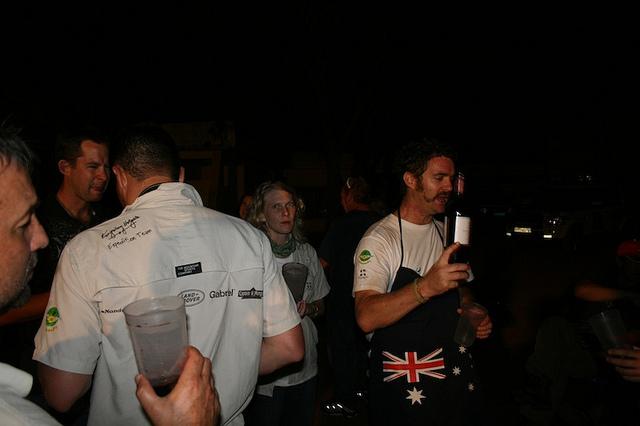How many bottles are seen?
Write a very short answer. 1. How many people?
Short answer required. 5. What are they celebrating?
Give a very brief answer. Birthday. Why are they standing this way?
Be succinct. Drinking. What is the man in the all white shirt holding?
Concise answer only. Wine. Are these guys having a celebration?
Quick response, please. Yes. What is behind the man?
Short answer required. People. What are the men holding?
Short answer required. Drinks. Is this a party?
Concise answer only. Yes. Do you see something on the men's heads?
Be succinct. No. What is this man carrying?
Concise answer only. Wine. How many umbrellas are visible in this photo?
Keep it brief. 0. Does the person holding the bottle have a mustache?
Concise answer only. Yes. How many bald men are shown?
Be succinct. 0. What country's flag is on the stage?
Be succinct. Uk. What flags are pictured?
Keep it brief. Australian. How many women do you see?
Write a very short answer. 1. What beverage is the man drinking?
Quick response, please. Wine. What are the people doing?
Be succinct. Drinking. Is the man wearing glasses?
Short answer required. No. Are they on a pier?
Be succinct. No. How many people are in the picture?
Concise answer only. 6. What are the men standing around?
Write a very short answer. Bar. 